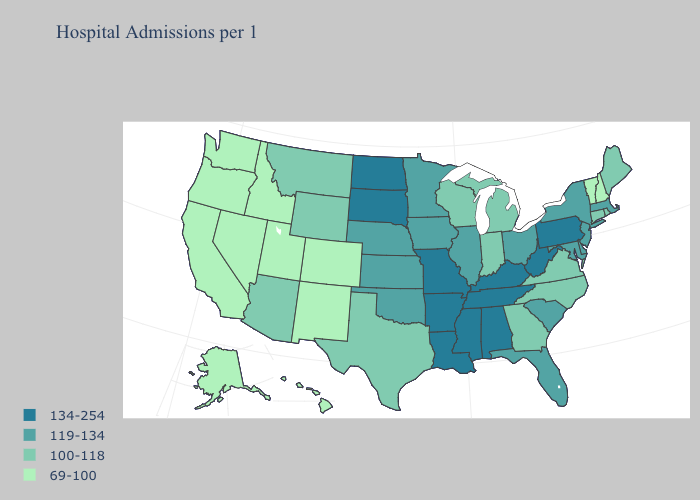Which states have the highest value in the USA?
Short answer required. Alabama, Arkansas, Kentucky, Louisiana, Mississippi, Missouri, North Dakota, Pennsylvania, South Dakota, Tennessee, West Virginia. Which states have the lowest value in the West?
Concise answer only. Alaska, California, Colorado, Hawaii, Idaho, Nevada, New Mexico, Oregon, Utah, Washington. Does West Virginia have the lowest value in the USA?
Give a very brief answer. No. What is the highest value in states that border Oregon?
Write a very short answer. 69-100. Which states have the highest value in the USA?
Keep it brief. Alabama, Arkansas, Kentucky, Louisiana, Mississippi, Missouri, North Dakota, Pennsylvania, South Dakota, Tennessee, West Virginia. Is the legend a continuous bar?
Write a very short answer. No. Among the states that border Wyoming , does South Dakota have the lowest value?
Quick response, please. No. What is the highest value in the USA?
Keep it brief. 134-254. Name the states that have a value in the range 119-134?
Give a very brief answer. Delaware, Florida, Illinois, Iowa, Kansas, Maryland, Massachusetts, Minnesota, Nebraska, New Jersey, New York, Ohio, Oklahoma, South Carolina. What is the value of Ohio?
Short answer required. 119-134. What is the value of California?
Short answer required. 69-100. Does Iowa have a lower value than Idaho?
Concise answer only. No. What is the lowest value in states that border Oregon?
Short answer required. 69-100. Which states have the highest value in the USA?
Answer briefly. Alabama, Arkansas, Kentucky, Louisiana, Mississippi, Missouri, North Dakota, Pennsylvania, South Dakota, Tennessee, West Virginia. What is the lowest value in the USA?
Concise answer only. 69-100. 